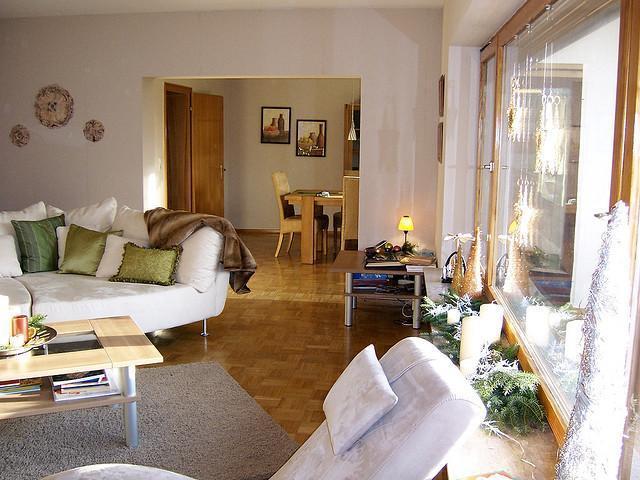How many couches can you see?
Give a very brief answer. 2. How many chairs are in the photo?
Give a very brief answer. 1. How many potted plants are in the picture?
Give a very brief answer. 1. 